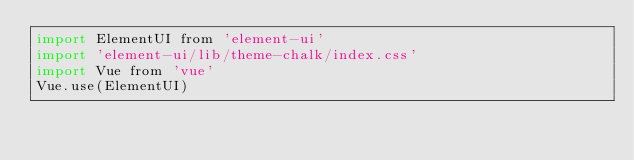Convert code to text. <code><loc_0><loc_0><loc_500><loc_500><_JavaScript_>import ElementUI from 'element-ui'
import 'element-ui/lib/theme-chalk/index.css'
import Vue from 'vue'
Vue.use(ElementUI)
</code> 